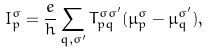Convert formula to latex. <formula><loc_0><loc_0><loc_500><loc_500>I ^ { \sigma } _ { p } = \frac { e } { h } \sum _ { q , \sigma ^ { \prime } } T _ { p q } ^ { \sigma \sigma ^ { \prime } } ( \mu ^ { \sigma } _ { p } - \mu ^ { \sigma ^ { \prime } } _ { q } ) ,</formula> 